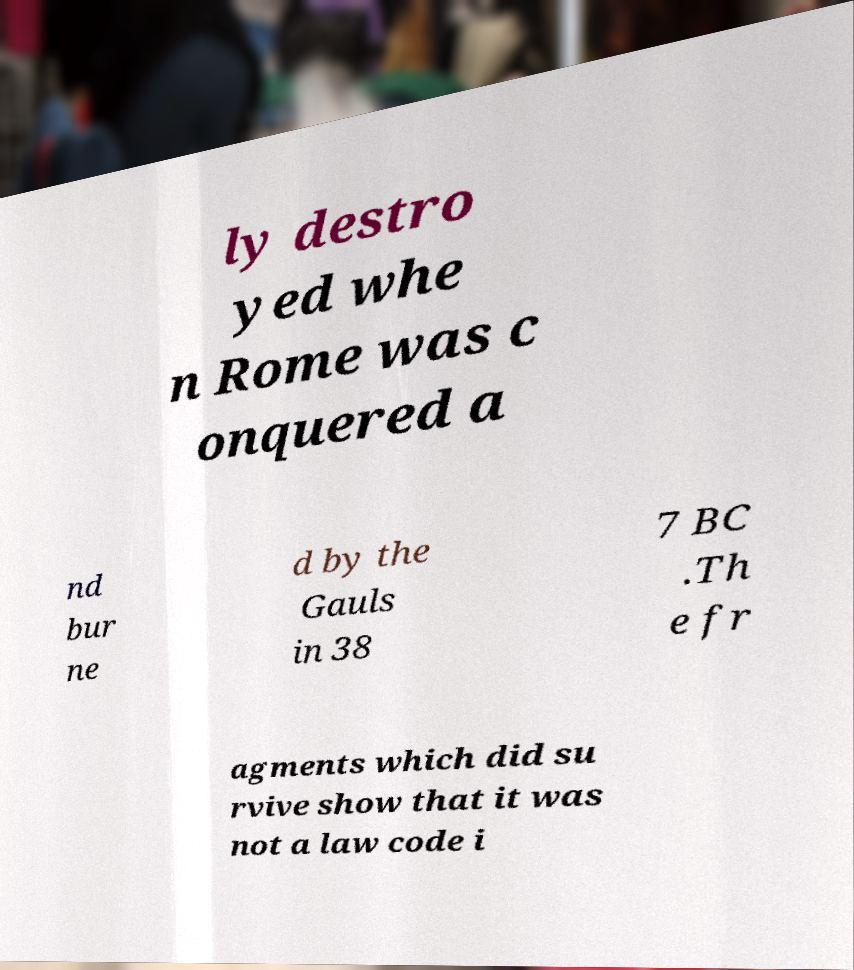Please identify and transcribe the text found in this image. ly destro yed whe n Rome was c onquered a nd bur ne d by the Gauls in 38 7 BC .Th e fr agments which did su rvive show that it was not a law code i 